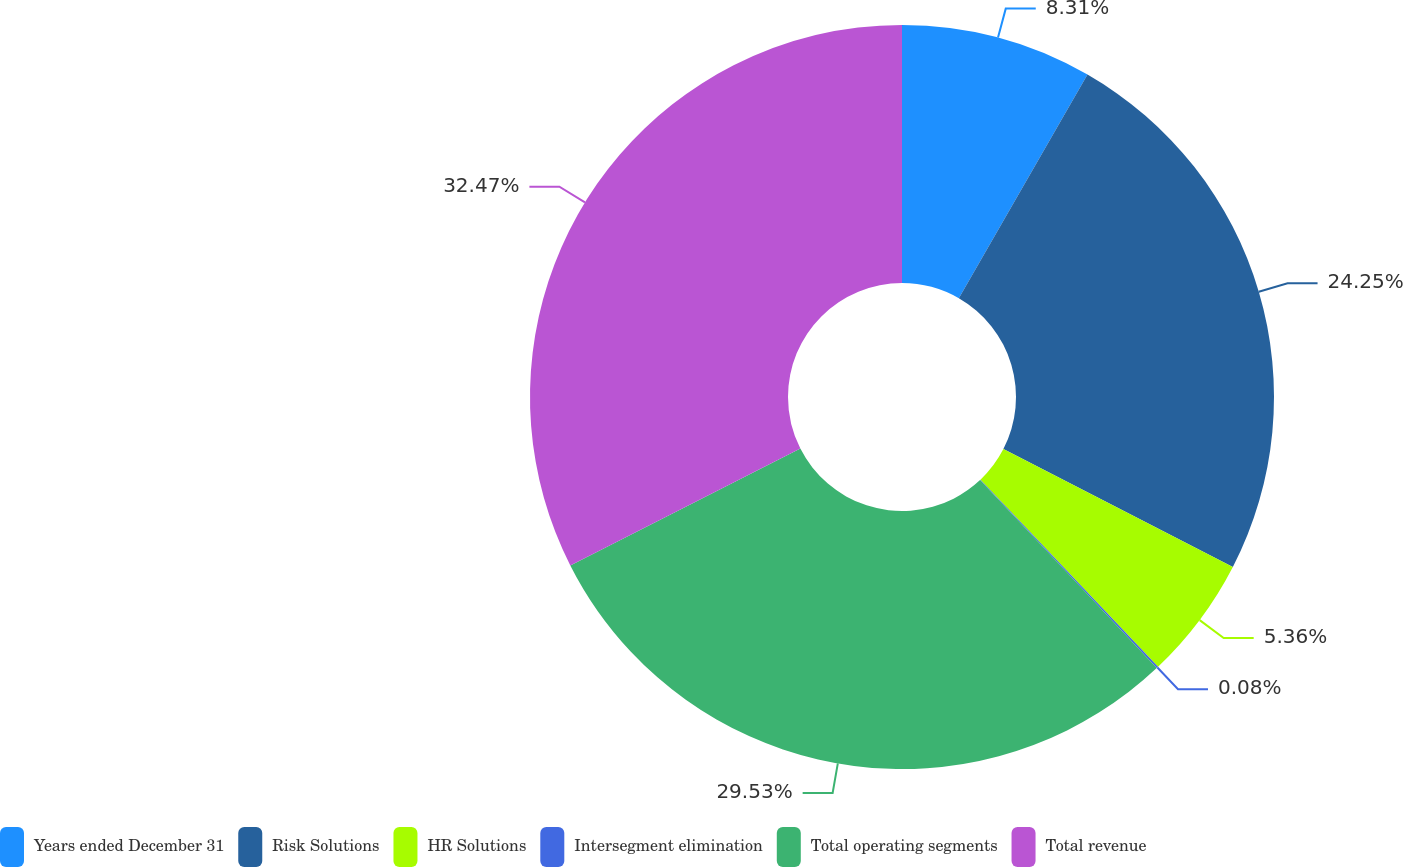Convert chart to OTSL. <chart><loc_0><loc_0><loc_500><loc_500><pie_chart><fcel>Years ended December 31<fcel>Risk Solutions<fcel>HR Solutions<fcel>Intersegment elimination<fcel>Total operating segments<fcel>Total revenue<nl><fcel>8.31%<fcel>24.25%<fcel>5.36%<fcel>0.08%<fcel>29.53%<fcel>32.48%<nl></chart> 